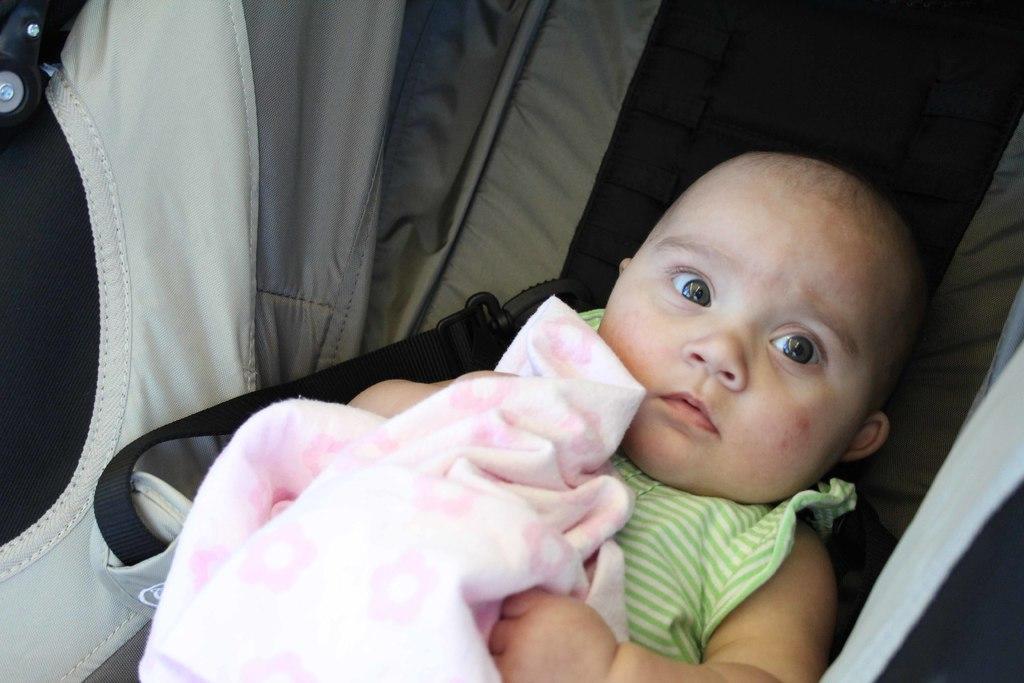Can you describe this image briefly? In the foreground of this image, it seems like there is a baby in the baby cart and there is a pink color cloth on the baby. 